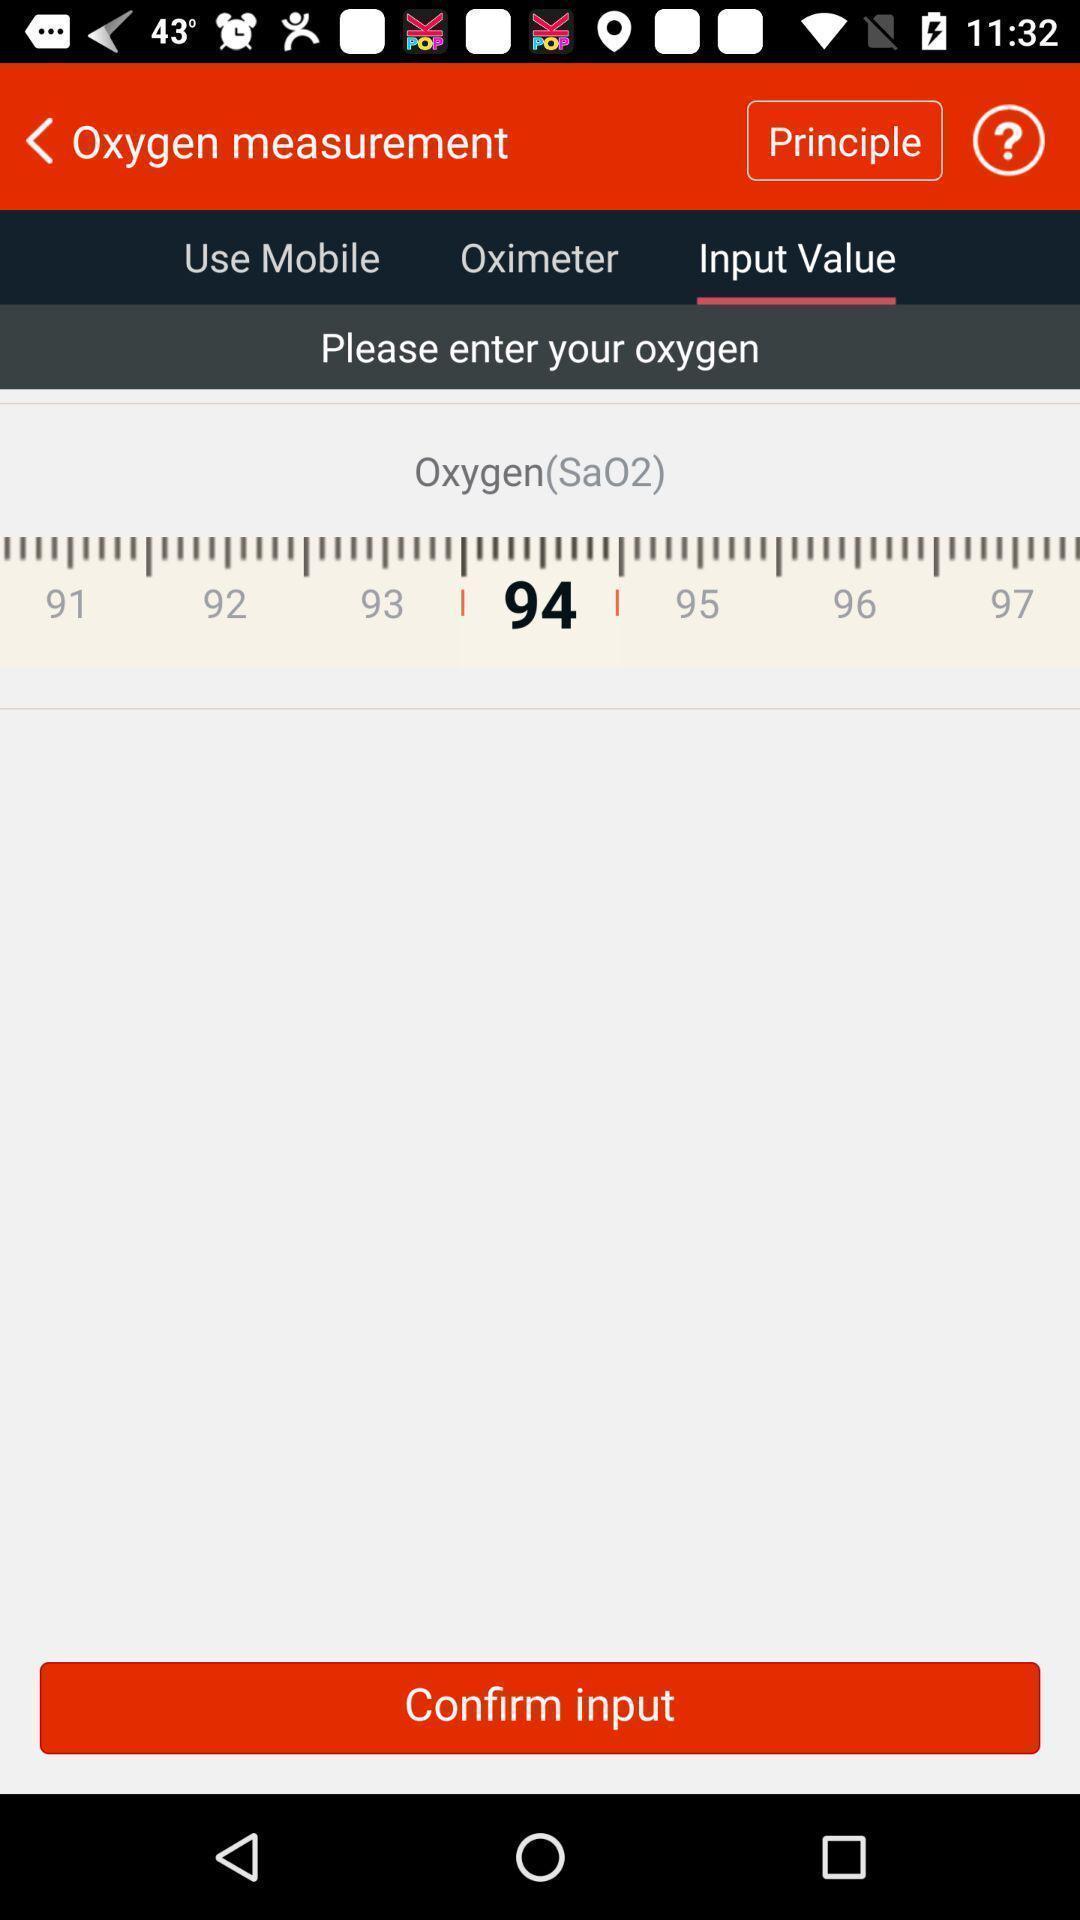Summarize the main components in this picture. Page shows to confirm input. 